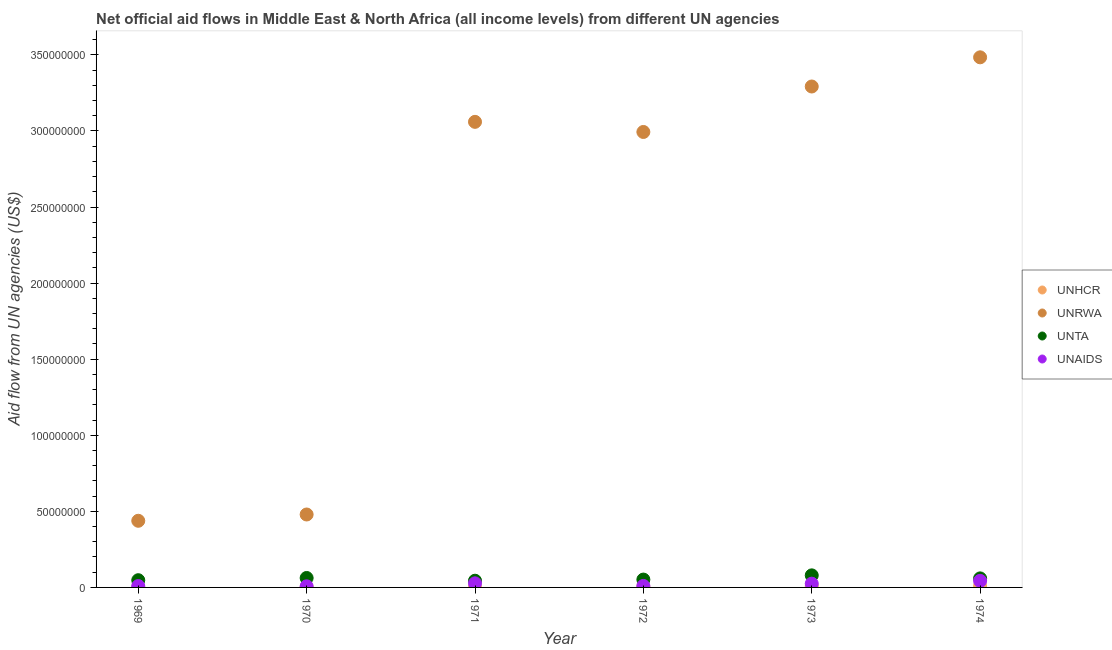How many different coloured dotlines are there?
Make the answer very short. 4. What is the amount of aid given by unrwa in 1972?
Give a very brief answer. 2.99e+08. Across all years, what is the maximum amount of aid given by unta?
Keep it short and to the point. 7.93e+06. Across all years, what is the minimum amount of aid given by unaids?
Give a very brief answer. 7.40e+05. In which year was the amount of aid given by unrwa maximum?
Your answer should be compact. 1974. In which year was the amount of aid given by unta minimum?
Offer a terse response. 1971. What is the total amount of aid given by unaids in the graph?
Your response must be concise. 1.21e+07. What is the difference between the amount of aid given by unta in 1974 and the amount of aid given by unaids in 1970?
Offer a very short reply. 5.20e+06. What is the average amount of aid given by unaids per year?
Your answer should be very brief. 2.02e+06. In the year 1973, what is the difference between the amount of aid given by unta and amount of aid given by unaids?
Give a very brief answer. 5.46e+06. In how many years, is the amount of aid given by unaids greater than 120000000 US$?
Provide a short and direct response. 0. What is the ratio of the amount of aid given by unaids in 1970 to that in 1974?
Your answer should be compact. 0.17. What is the difference between the highest and the second highest amount of aid given by unaids?
Offer a terse response. 1.64e+06. What is the difference between the highest and the lowest amount of aid given by unaids?
Your answer should be compact. 3.58e+06. Does the amount of aid given by unta monotonically increase over the years?
Offer a very short reply. No. Is the amount of aid given by unhcr strictly greater than the amount of aid given by unaids over the years?
Your answer should be very brief. No. Is the amount of aid given by unrwa strictly less than the amount of aid given by unta over the years?
Keep it short and to the point. No. How many dotlines are there?
Give a very brief answer. 4. Does the graph contain grids?
Make the answer very short. No. Where does the legend appear in the graph?
Make the answer very short. Center right. How are the legend labels stacked?
Offer a very short reply. Vertical. What is the title of the graph?
Ensure brevity in your answer.  Net official aid flows in Middle East & North Africa (all income levels) from different UN agencies. Does "First 20% of population" appear as one of the legend labels in the graph?
Your answer should be compact. No. What is the label or title of the Y-axis?
Provide a succinct answer. Aid flow from UN agencies (US$). What is the Aid flow from UN agencies (US$) in UNHCR in 1969?
Keep it short and to the point. 1.40e+05. What is the Aid flow from UN agencies (US$) of UNRWA in 1969?
Your answer should be very brief. 4.38e+07. What is the Aid flow from UN agencies (US$) of UNTA in 1969?
Provide a succinct answer. 4.75e+06. What is the Aid flow from UN agencies (US$) in UNAIDS in 1969?
Provide a succinct answer. 9.10e+05. What is the Aid flow from UN agencies (US$) in UNHCR in 1970?
Offer a very short reply. 1.70e+05. What is the Aid flow from UN agencies (US$) in UNRWA in 1970?
Offer a very short reply. 4.79e+07. What is the Aid flow from UN agencies (US$) in UNTA in 1970?
Offer a very short reply. 6.21e+06. What is the Aid flow from UN agencies (US$) of UNAIDS in 1970?
Your response must be concise. 7.40e+05. What is the Aid flow from UN agencies (US$) of UNHCR in 1971?
Give a very brief answer. 1.40e+05. What is the Aid flow from UN agencies (US$) of UNRWA in 1971?
Ensure brevity in your answer.  3.06e+08. What is the Aid flow from UN agencies (US$) of UNTA in 1971?
Your answer should be very brief. 4.41e+06. What is the Aid flow from UN agencies (US$) in UNAIDS in 1971?
Ensure brevity in your answer.  2.68e+06. What is the Aid flow from UN agencies (US$) in UNRWA in 1972?
Ensure brevity in your answer.  2.99e+08. What is the Aid flow from UN agencies (US$) in UNTA in 1972?
Provide a succinct answer. 5.16e+06. What is the Aid flow from UN agencies (US$) in UNAIDS in 1972?
Give a very brief answer. 9.80e+05. What is the Aid flow from UN agencies (US$) of UNHCR in 1973?
Your response must be concise. 8.80e+05. What is the Aid flow from UN agencies (US$) of UNRWA in 1973?
Ensure brevity in your answer.  3.29e+08. What is the Aid flow from UN agencies (US$) in UNTA in 1973?
Give a very brief answer. 7.93e+06. What is the Aid flow from UN agencies (US$) in UNAIDS in 1973?
Provide a short and direct response. 2.47e+06. What is the Aid flow from UN agencies (US$) of UNHCR in 1974?
Ensure brevity in your answer.  9.70e+05. What is the Aid flow from UN agencies (US$) of UNRWA in 1974?
Keep it short and to the point. 3.48e+08. What is the Aid flow from UN agencies (US$) of UNTA in 1974?
Give a very brief answer. 5.94e+06. What is the Aid flow from UN agencies (US$) in UNAIDS in 1974?
Keep it short and to the point. 4.32e+06. Across all years, what is the maximum Aid flow from UN agencies (US$) of UNHCR?
Give a very brief answer. 9.70e+05. Across all years, what is the maximum Aid flow from UN agencies (US$) in UNRWA?
Ensure brevity in your answer.  3.48e+08. Across all years, what is the maximum Aid flow from UN agencies (US$) of UNTA?
Provide a succinct answer. 7.93e+06. Across all years, what is the maximum Aid flow from UN agencies (US$) in UNAIDS?
Your answer should be compact. 4.32e+06. Across all years, what is the minimum Aid flow from UN agencies (US$) of UNHCR?
Your answer should be compact. 1.40e+05. Across all years, what is the minimum Aid flow from UN agencies (US$) in UNRWA?
Offer a very short reply. 4.38e+07. Across all years, what is the minimum Aid flow from UN agencies (US$) in UNTA?
Provide a succinct answer. 4.41e+06. Across all years, what is the minimum Aid flow from UN agencies (US$) in UNAIDS?
Keep it short and to the point. 7.40e+05. What is the total Aid flow from UN agencies (US$) in UNHCR in the graph?
Ensure brevity in your answer.  2.76e+06. What is the total Aid flow from UN agencies (US$) of UNRWA in the graph?
Provide a succinct answer. 1.37e+09. What is the total Aid flow from UN agencies (US$) in UNTA in the graph?
Make the answer very short. 3.44e+07. What is the total Aid flow from UN agencies (US$) of UNAIDS in the graph?
Provide a short and direct response. 1.21e+07. What is the difference between the Aid flow from UN agencies (US$) in UNRWA in 1969 and that in 1970?
Offer a terse response. -4.13e+06. What is the difference between the Aid flow from UN agencies (US$) of UNTA in 1969 and that in 1970?
Your answer should be compact. -1.46e+06. What is the difference between the Aid flow from UN agencies (US$) of UNAIDS in 1969 and that in 1970?
Make the answer very short. 1.70e+05. What is the difference between the Aid flow from UN agencies (US$) in UNRWA in 1969 and that in 1971?
Provide a succinct answer. -2.62e+08. What is the difference between the Aid flow from UN agencies (US$) of UNAIDS in 1969 and that in 1971?
Your answer should be compact. -1.77e+06. What is the difference between the Aid flow from UN agencies (US$) in UNHCR in 1969 and that in 1972?
Provide a short and direct response. -3.20e+05. What is the difference between the Aid flow from UN agencies (US$) of UNRWA in 1969 and that in 1972?
Ensure brevity in your answer.  -2.56e+08. What is the difference between the Aid flow from UN agencies (US$) in UNTA in 1969 and that in 1972?
Keep it short and to the point. -4.10e+05. What is the difference between the Aid flow from UN agencies (US$) in UNAIDS in 1969 and that in 1972?
Provide a succinct answer. -7.00e+04. What is the difference between the Aid flow from UN agencies (US$) of UNHCR in 1969 and that in 1973?
Offer a terse response. -7.40e+05. What is the difference between the Aid flow from UN agencies (US$) in UNRWA in 1969 and that in 1973?
Your answer should be very brief. -2.85e+08. What is the difference between the Aid flow from UN agencies (US$) in UNTA in 1969 and that in 1973?
Give a very brief answer. -3.18e+06. What is the difference between the Aid flow from UN agencies (US$) of UNAIDS in 1969 and that in 1973?
Keep it short and to the point. -1.56e+06. What is the difference between the Aid flow from UN agencies (US$) of UNHCR in 1969 and that in 1974?
Make the answer very short. -8.30e+05. What is the difference between the Aid flow from UN agencies (US$) of UNRWA in 1969 and that in 1974?
Your answer should be compact. -3.05e+08. What is the difference between the Aid flow from UN agencies (US$) of UNTA in 1969 and that in 1974?
Keep it short and to the point. -1.19e+06. What is the difference between the Aid flow from UN agencies (US$) of UNAIDS in 1969 and that in 1974?
Make the answer very short. -3.41e+06. What is the difference between the Aid flow from UN agencies (US$) of UNRWA in 1970 and that in 1971?
Ensure brevity in your answer.  -2.58e+08. What is the difference between the Aid flow from UN agencies (US$) of UNTA in 1970 and that in 1971?
Make the answer very short. 1.80e+06. What is the difference between the Aid flow from UN agencies (US$) of UNAIDS in 1970 and that in 1971?
Give a very brief answer. -1.94e+06. What is the difference between the Aid flow from UN agencies (US$) in UNRWA in 1970 and that in 1972?
Offer a terse response. -2.51e+08. What is the difference between the Aid flow from UN agencies (US$) in UNTA in 1970 and that in 1972?
Keep it short and to the point. 1.05e+06. What is the difference between the Aid flow from UN agencies (US$) of UNAIDS in 1970 and that in 1972?
Your answer should be very brief. -2.40e+05. What is the difference between the Aid flow from UN agencies (US$) of UNHCR in 1970 and that in 1973?
Keep it short and to the point. -7.10e+05. What is the difference between the Aid flow from UN agencies (US$) of UNRWA in 1970 and that in 1973?
Ensure brevity in your answer.  -2.81e+08. What is the difference between the Aid flow from UN agencies (US$) in UNTA in 1970 and that in 1973?
Your answer should be very brief. -1.72e+06. What is the difference between the Aid flow from UN agencies (US$) of UNAIDS in 1970 and that in 1973?
Your answer should be compact. -1.73e+06. What is the difference between the Aid flow from UN agencies (US$) in UNHCR in 1970 and that in 1974?
Make the answer very short. -8.00e+05. What is the difference between the Aid flow from UN agencies (US$) in UNRWA in 1970 and that in 1974?
Give a very brief answer. -3.00e+08. What is the difference between the Aid flow from UN agencies (US$) of UNTA in 1970 and that in 1974?
Offer a terse response. 2.70e+05. What is the difference between the Aid flow from UN agencies (US$) of UNAIDS in 1970 and that in 1974?
Offer a terse response. -3.58e+06. What is the difference between the Aid flow from UN agencies (US$) of UNHCR in 1971 and that in 1972?
Your response must be concise. -3.20e+05. What is the difference between the Aid flow from UN agencies (US$) in UNRWA in 1971 and that in 1972?
Provide a short and direct response. 6.65e+06. What is the difference between the Aid flow from UN agencies (US$) of UNTA in 1971 and that in 1972?
Offer a very short reply. -7.50e+05. What is the difference between the Aid flow from UN agencies (US$) of UNAIDS in 1971 and that in 1972?
Your answer should be very brief. 1.70e+06. What is the difference between the Aid flow from UN agencies (US$) in UNHCR in 1971 and that in 1973?
Give a very brief answer. -7.40e+05. What is the difference between the Aid flow from UN agencies (US$) in UNRWA in 1971 and that in 1973?
Give a very brief answer. -2.32e+07. What is the difference between the Aid flow from UN agencies (US$) of UNTA in 1971 and that in 1973?
Give a very brief answer. -3.52e+06. What is the difference between the Aid flow from UN agencies (US$) of UNHCR in 1971 and that in 1974?
Your answer should be very brief. -8.30e+05. What is the difference between the Aid flow from UN agencies (US$) of UNRWA in 1971 and that in 1974?
Your answer should be very brief. -4.24e+07. What is the difference between the Aid flow from UN agencies (US$) of UNTA in 1971 and that in 1974?
Offer a terse response. -1.53e+06. What is the difference between the Aid flow from UN agencies (US$) of UNAIDS in 1971 and that in 1974?
Ensure brevity in your answer.  -1.64e+06. What is the difference between the Aid flow from UN agencies (US$) of UNHCR in 1972 and that in 1973?
Your answer should be compact. -4.20e+05. What is the difference between the Aid flow from UN agencies (US$) of UNRWA in 1972 and that in 1973?
Ensure brevity in your answer.  -2.99e+07. What is the difference between the Aid flow from UN agencies (US$) of UNTA in 1972 and that in 1973?
Provide a succinct answer. -2.77e+06. What is the difference between the Aid flow from UN agencies (US$) of UNAIDS in 1972 and that in 1973?
Your response must be concise. -1.49e+06. What is the difference between the Aid flow from UN agencies (US$) in UNHCR in 1972 and that in 1974?
Your response must be concise. -5.10e+05. What is the difference between the Aid flow from UN agencies (US$) in UNRWA in 1972 and that in 1974?
Offer a terse response. -4.91e+07. What is the difference between the Aid flow from UN agencies (US$) in UNTA in 1972 and that in 1974?
Your answer should be very brief. -7.80e+05. What is the difference between the Aid flow from UN agencies (US$) of UNAIDS in 1972 and that in 1974?
Offer a very short reply. -3.34e+06. What is the difference between the Aid flow from UN agencies (US$) of UNRWA in 1973 and that in 1974?
Your answer should be very brief. -1.92e+07. What is the difference between the Aid flow from UN agencies (US$) of UNTA in 1973 and that in 1974?
Give a very brief answer. 1.99e+06. What is the difference between the Aid flow from UN agencies (US$) in UNAIDS in 1973 and that in 1974?
Offer a terse response. -1.85e+06. What is the difference between the Aid flow from UN agencies (US$) in UNHCR in 1969 and the Aid flow from UN agencies (US$) in UNRWA in 1970?
Your answer should be very brief. -4.78e+07. What is the difference between the Aid flow from UN agencies (US$) in UNHCR in 1969 and the Aid flow from UN agencies (US$) in UNTA in 1970?
Provide a short and direct response. -6.07e+06. What is the difference between the Aid flow from UN agencies (US$) in UNHCR in 1969 and the Aid flow from UN agencies (US$) in UNAIDS in 1970?
Provide a succinct answer. -6.00e+05. What is the difference between the Aid flow from UN agencies (US$) of UNRWA in 1969 and the Aid flow from UN agencies (US$) of UNTA in 1970?
Your answer should be very brief. 3.76e+07. What is the difference between the Aid flow from UN agencies (US$) in UNRWA in 1969 and the Aid flow from UN agencies (US$) in UNAIDS in 1970?
Ensure brevity in your answer.  4.31e+07. What is the difference between the Aid flow from UN agencies (US$) of UNTA in 1969 and the Aid flow from UN agencies (US$) of UNAIDS in 1970?
Provide a short and direct response. 4.01e+06. What is the difference between the Aid flow from UN agencies (US$) in UNHCR in 1969 and the Aid flow from UN agencies (US$) in UNRWA in 1971?
Your response must be concise. -3.06e+08. What is the difference between the Aid flow from UN agencies (US$) of UNHCR in 1969 and the Aid flow from UN agencies (US$) of UNTA in 1971?
Provide a succinct answer. -4.27e+06. What is the difference between the Aid flow from UN agencies (US$) in UNHCR in 1969 and the Aid flow from UN agencies (US$) in UNAIDS in 1971?
Your answer should be very brief. -2.54e+06. What is the difference between the Aid flow from UN agencies (US$) in UNRWA in 1969 and the Aid flow from UN agencies (US$) in UNTA in 1971?
Offer a terse response. 3.94e+07. What is the difference between the Aid flow from UN agencies (US$) in UNRWA in 1969 and the Aid flow from UN agencies (US$) in UNAIDS in 1971?
Provide a succinct answer. 4.11e+07. What is the difference between the Aid flow from UN agencies (US$) of UNTA in 1969 and the Aid flow from UN agencies (US$) of UNAIDS in 1971?
Your answer should be very brief. 2.07e+06. What is the difference between the Aid flow from UN agencies (US$) in UNHCR in 1969 and the Aid flow from UN agencies (US$) in UNRWA in 1972?
Offer a terse response. -2.99e+08. What is the difference between the Aid flow from UN agencies (US$) of UNHCR in 1969 and the Aid flow from UN agencies (US$) of UNTA in 1972?
Provide a short and direct response. -5.02e+06. What is the difference between the Aid flow from UN agencies (US$) in UNHCR in 1969 and the Aid flow from UN agencies (US$) in UNAIDS in 1972?
Your answer should be very brief. -8.40e+05. What is the difference between the Aid flow from UN agencies (US$) in UNRWA in 1969 and the Aid flow from UN agencies (US$) in UNTA in 1972?
Keep it short and to the point. 3.86e+07. What is the difference between the Aid flow from UN agencies (US$) in UNRWA in 1969 and the Aid flow from UN agencies (US$) in UNAIDS in 1972?
Make the answer very short. 4.28e+07. What is the difference between the Aid flow from UN agencies (US$) in UNTA in 1969 and the Aid flow from UN agencies (US$) in UNAIDS in 1972?
Keep it short and to the point. 3.77e+06. What is the difference between the Aid flow from UN agencies (US$) in UNHCR in 1969 and the Aid flow from UN agencies (US$) in UNRWA in 1973?
Give a very brief answer. -3.29e+08. What is the difference between the Aid flow from UN agencies (US$) of UNHCR in 1969 and the Aid flow from UN agencies (US$) of UNTA in 1973?
Give a very brief answer. -7.79e+06. What is the difference between the Aid flow from UN agencies (US$) in UNHCR in 1969 and the Aid flow from UN agencies (US$) in UNAIDS in 1973?
Keep it short and to the point. -2.33e+06. What is the difference between the Aid flow from UN agencies (US$) of UNRWA in 1969 and the Aid flow from UN agencies (US$) of UNTA in 1973?
Ensure brevity in your answer.  3.59e+07. What is the difference between the Aid flow from UN agencies (US$) of UNRWA in 1969 and the Aid flow from UN agencies (US$) of UNAIDS in 1973?
Provide a succinct answer. 4.13e+07. What is the difference between the Aid flow from UN agencies (US$) of UNTA in 1969 and the Aid flow from UN agencies (US$) of UNAIDS in 1973?
Ensure brevity in your answer.  2.28e+06. What is the difference between the Aid flow from UN agencies (US$) of UNHCR in 1969 and the Aid flow from UN agencies (US$) of UNRWA in 1974?
Your response must be concise. -3.48e+08. What is the difference between the Aid flow from UN agencies (US$) in UNHCR in 1969 and the Aid flow from UN agencies (US$) in UNTA in 1974?
Your answer should be very brief. -5.80e+06. What is the difference between the Aid flow from UN agencies (US$) of UNHCR in 1969 and the Aid flow from UN agencies (US$) of UNAIDS in 1974?
Offer a very short reply. -4.18e+06. What is the difference between the Aid flow from UN agencies (US$) in UNRWA in 1969 and the Aid flow from UN agencies (US$) in UNTA in 1974?
Give a very brief answer. 3.79e+07. What is the difference between the Aid flow from UN agencies (US$) of UNRWA in 1969 and the Aid flow from UN agencies (US$) of UNAIDS in 1974?
Offer a terse response. 3.95e+07. What is the difference between the Aid flow from UN agencies (US$) in UNHCR in 1970 and the Aid flow from UN agencies (US$) in UNRWA in 1971?
Your answer should be compact. -3.06e+08. What is the difference between the Aid flow from UN agencies (US$) of UNHCR in 1970 and the Aid flow from UN agencies (US$) of UNTA in 1971?
Provide a succinct answer. -4.24e+06. What is the difference between the Aid flow from UN agencies (US$) in UNHCR in 1970 and the Aid flow from UN agencies (US$) in UNAIDS in 1971?
Provide a succinct answer. -2.51e+06. What is the difference between the Aid flow from UN agencies (US$) of UNRWA in 1970 and the Aid flow from UN agencies (US$) of UNTA in 1971?
Offer a terse response. 4.35e+07. What is the difference between the Aid flow from UN agencies (US$) of UNRWA in 1970 and the Aid flow from UN agencies (US$) of UNAIDS in 1971?
Make the answer very short. 4.52e+07. What is the difference between the Aid flow from UN agencies (US$) of UNTA in 1970 and the Aid flow from UN agencies (US$) of UNAIDS in 1971?
Make the answer very short. 3.53e+06. What is the difference between the Aid flow from UN agencies (US$) of UNHCR in 1970 and the Aid flow from UN agencies (US$) of UNRWA in 1972?
Provide a succinct answer. -2.99e+08. What is the difference between the Aid flow from UN agencies (US$) of UNHCR in 1970 and the Aid flow from UN agencies (US$) of UNTA in 1972?
Your answer should be very brief. -4.99e+06. What is the difference between the Aid flow from UN agencies (US$) of UNHCR in 1970 and the Aid flow from UN agencies (US$) of UNAIDS in 1972?
Offer a very short reply. -8.10e+05. What is the difference between the Aid flow from UN agencies (US$) in UNRWA in 1970 and the Aid flow from UN agencies (US$) in UNTA in 1972?
Your answer should be very brief. 4.28e+07. What is the difference between the Aid flow from UN agencies (US$) in UNRWA in 1970 and the Aid flow from UN agencies (US$) in UNAIDS in 1972?
Give a very brief answer. 4.70e+07. What is the difference between the Aid flow from UN agencies (US$) in UNTA in 1970 and the Aid flow from UN agencies (US$) in UNAIDS in 1972?
Keep it short and to the point. 5.23e+06. What is the difference between the Aid flow from UN agencies (US$) in UNHCR in 1970 and the Aid flow from UN agencies (US$) in UNRWA in 1973?
Ensure brevity in your answer.  -3.29e+08. What is the difference between the Aid flow from UN agencies (US$) of UNHCR in 1970 and the Aid flow from UN agencies (US$) of UNTA in 1973?
Your answer should be very brief. -7.76e+06. What is the difference between the Aid flow from UN agencies (US$) of UNHCR in 1970 and the Aid flow from UN agencies (US$) of UNAIDS in 1973?
Your answer should be very brief. -2.30e+06. What is the difference between the Aid flow from UN agencies (US$) in UNRWA in 1970 and the Aid flow from UN agencies (US$) in UNTA in 1973?
Your answer should be compact. 4.00e+07. What is the difference between the Aid flow from UN agencies (US$) in UNRWA in 1970 and the Aid flow from UN agencies (US$) in UNAIDS in 1973?
Your answer should be compact. 4.55e+07. What is the difference between the Aid flow from UN agencies (US$) in UNTA in 1970 and the Aid flow from UN agencies (US$) in UNAIDS in 1973?
Make the answer very short. 3.74e+06. What is the difference between the Aid flow from UN agencies (US$) of UNHCR in 1970 and the Aid flow from UN agencies (US$) of UNRWA in 1974?
Keep it short and to the point. -3.48e+08. What is the difference between the Aid flow from UN agencies (US$) of UNHCR in 1970 and the Aid flow from UN agencies (US$) of UNTA in 1974?
Provide a short and direct response. -5.77e+06. What is the difference between the Aid flow from UN agencies (US$) of UNHCR in 1970 and the Aid flow from UN agencies (US$) of UNAIDS in 1974?
Your answer should be compact. -4.15e+06. What is the difference between the Aid flow from UN agencies (US$) in UNRWA in 1970 and the Aid flow from UN agencies (US$) in UNTA in 1974?
Provide a succinct answer. 4.20e+07. What is the difference between the Aid flow from UN agencies (US$) in UNRWA in 1970 and the Aid flow from UN agencies (US$) in UNAIDS in 1974?
Offer a very short reply. 4.36e+07. What is the difference between the Aid flow from UN agencies (US$) of UNTA in 1970 and the Aid flow from UN agencies (US$) of UNAIDS in 1974?
Offer a very short reply. 1.89e+06. What is the difference between the Aid flow from UN agencies (US$) of UNHCR in 1971 and the Aid flow from UN agencies (US$) of UNRWA in 1972?
Keep it short and to the point. -2.99e+08. What is the difference between the Aid flow from UN agencies (US$) in UNHCR in 1971 and the Aid flow from UN agencies (US$) in UNTA in 1972?
Your answer should be very brief. -5.02e+06. What is the difference between the Aid flow from UN agencies (US$) of UNHCR in 1971 and the Aid flow from UN agencies (US$) of UNAIDS in 1972?
Make the answer very short. -8.40e+05. What is the difference between the Aid flow from UN agencies (US$) in UNRWA in 1971 and the Aid flow from UN agencies (US$) in UNTA in 1972?
Your answer should be compact. 3.01e+08. What is the difference between the Aid flow from UN agencies (US$) in UNRWA in 1971 and the Aid flow from UN agencies (US$) in UNAIDS in 1972?
Keep it short and to the point. 3.05e+08. What is the difference between the Aid flow from UN agencies (US$) of UNTA in 1971 and the Aid flow from UN agencies (US$) of UNAIDS in 1972?
Offer a terse response. 3.43e+06. What is the difference between the Aid flow from UN agencies (US$) in UNHCR in 1971 and the Aid flow from UN agencies (US$) in UNRWA in 1973?
Your response must be concise. -3.29e+08. What is the difference between the Aid flow from UN agencies (US$) in UNHCR in 1971 and the Aid flow from UN agencies (US$) in UNTA in 1973?
Your answer should be very brief. -7.79e+06. What is the difference between the Aid flow from UN agencies (US$) in UNHCR in 1971 and the Aid flow from UN agencies (US$) in UNAIDS in 1973?
Your answer should be compact. -2.33e+06. What is the difference between the Aid flow from UN agencies (US$) in UNRWA in 1971 and the Aid flow from UN agencies (US$) in UNTA in 1973?
Your answer should be very brief. 2.98e+08. What is the difference between the Aid flow from UN agencies (US$) in UNRWA in 1971 and the Aid flow from UN agencies (US$) in UNAIDS in 1973?
Your response must be concise. 3.04e+08. What is the difference between the Aid flow from UN agencies (US$) in UNTA in 1971 and the Aid flow from UN agencies (US$) in UNAIDS in 1973?
Your answer should be very brief. 1.94e+06. What is the difference between the Aid flow from UN agencies (US$) in UNHCR in 1971 and the Aid flow from UN agencies (US$) in UNRWA in 1974?
Your answer should be very brief. -3.48e+08. What is the difference between the Aid flow from UN agencies (US$) in UNHCR in 1971 and the Aid flow from UN agencies (US$) in UNTA in 1974?
Provide a succinct answer. -5.80e+06. What is the difference between the Aid flow from UN agencies (US$) of UNHCR in 1971 and the Aid flow from UN agencies (US$) of UNAIDS in 1974?
Offer a terse response. -4.18e+06. What is the difference between the Aid flow from UN agencies (US$) of UNRWA in 1971 and the Aid flow from UN agencies (US$) of UNTA in 1974?
Offer a terse response. 3.00e+08. What is the difference between the Aid flow from UN agencies (US$) in UNRWA in 1971 and the Aid flow from UN agencies (US$) in UNAIDS in 1974?
Offer a very short reply. 3.02e+08. What is the difference between the Aid flow from UN agencies (US$) of UNTA in 1971 and the Aid flow from UN agencies (US$) of UNAIDS in 1974?
Provide a succinct answer. 9.00e+04. What is the difference between the Aid flow from UN agencies (US$) of UNHCR in 1972 and the Aid flow from UN agencies (US$) of UNRWA in 1973?
Ensure brevity in your answer.  -3.29e+08. What is the difference between the Aid flow from UN agencies (US$) in UNHCR in 1972 and the Aid flow from UN agencies (US$) in UNTA in 1973?
Provide a short and direct response. -7.47e+06. What is the difference between the Aid flow from UN agencies (US$) of UNHCR in 1972 and the Aid flow from UN agencies (US$) of UNAIDS in 1973?
Make the answer very short. -2.01e+06. What is the difference between the Aid flow from UN agencies (US$) in UNRWA in 1972 and the Aid flow from UN agencies (US$) in UNTA in 1973?
Offer a terse response. 2.91e+08. What is the difference between the Aid flow from UN agencies (US$) in UNRWA in 1972 and the Aid flow from UN agencies (US$) in UNAIDS in 1973?
Provide a succinct answer. 2.97e+08. What is the difference between the Aid flow from UN agencies (US$) of UNTA in 1972 and the Aid flow from UN agencies (US$) of UNAIDS in 1973?
Keep it short and to the point. 2.69e+06. What is the difference between the Aid flow from UN agencies (US$) of UNHCR in 1972 and the Aid flow from UN agencies (US$) of UNRWA in 1974?
Your answer should be compact. -3.48e+08. What is the difference between the Aid flow from UN agencies (US$) in UNHCR in 1972 and the Aid flow from UN agencies (US$) in UNTA in 1974?
Provide a short and direct response. -5.48e+06. What is the difference between the Aid flow from UN agencies (US$) of UNHCR in 1972 and the Aid flow from UN agencies (US$) of UNAIDS in 1974?
Your answer should be compact. -3.86e+06. What is the difference between the Aid flow from UN agencies (US$) in UNRWA in 1972 and the Aid flow from UN agencies (US$) in UNTA in 1974?
Make the answer very short. 2.93e+08. What is the difference between the Aid flow from UN agencies (US$) in UNRWA in 1972 and the Aid flow from UN agencies (US$) in UNAIDS in 1974?
Keep it short and to the point. 2.95e+08. What is the difference between the Aid flow from UN agencies (US$) of UNTA in 1972 and the Aid flow from UN agencies (US$) of UNAIDS in 1974?
Give a very brief answer. 8.40e+05. What is the difference between the Aid flow from UN agencies (US$) in UNHCR in 1973 and the Aid flow from UN agencies (US$) in UNRWA in 1974?
Your answer should be very brief. -3.48e+08. What is the difference between the Aid flow from UN agencies (US$) in UNHCR in 1973 and the Aid flow from UN agencies (US$) in UNTA in 1974?
Provide a short and direct response. -5.06e+06. What is the difference between the Aid flow from UN agencies (US$) of UNHCR in 1973 and the Aid flow from UN agencies (US$) of UNAIDS in 1974?
Your response must be concise. -3.44e+06. What is the difference between the Aid flow from UN agencies (US$) in UNRWA in 1973 and the Aid flow from UN agencies (US$) in UNTA in 1974?
Your answer should be compact. 3.23e+08. What is the difference between the Aid flow from UN agencies (US$) of UNRWA in 1973 and the Aid flow from UN agencies (US$) of UNAIDS in 1974?
Offer a very short reply. 3.25e+08. What is the difference between the Aid flow from UN agencies (US$) of UNTA in 1973 and the Aid flow from UN agencies (US$) of UNAIDS in 1974?
Offer a terse response. 3.61e+06. What is the average Aid flow from UN agencies (US$) of UNHCR per year?
Ensure brevity in your answer.  4.60e+05. What is the average Aid flow from UN agencies (US$) of UNRWA per year?
Ensure brevity in your answer.  2.29e+08. What is the average Aid flow from UN agencies (US$) in UNTA per year?
Make the answer very short. 5.73e+06. What is the average Aid flow from UN agencies (US$) of UNAIDS per year?
Ensure brevity in your answer.  2.02e+06. In the year 1969, what is the difference between the Aid flow from UN agencies (US$) of UNHCR and Aid flow from UN agencies (US$) of UNRWA?
Offer a very short reply. -4.37e+07. In the year 1969, what is the difference between the Aid flow from UN agencies (US$) of UNHCR and Aid flow from UN agencies (US$) of UNTA?
Offer a very short reply. -4.61e+06. In the year 1969, what is the difference between the Aid flow from UN agencies (US$) in UNHCR and Aid flow from UN agencies (US$) in UNAIDS?
Your response must be concise. -7.70e+05. In the year 1969, what is the difference between the Aid flow from UN agencies (US$) of UNRWA and Aid flow from UN agencies (US$) of UNTA?
Ensure brevity in your answer.  3.90e+07. In the year 1969, what is the difference between the Aid flow from UN agencies (US$) in UNRWA and Aid flow from UN agencies (US$) in UNAIDS?
Your answer should be very brief. 4.29e+07. In the year 1969, what is the difference between the Aid flow from UN agencies (US$) of UNTA and Aid flow from UN agencies (US$) of UNAIDS?
Provide a short and direct response. 3.84e+06. In the year 1970, what is the difference between the Aid flow from UN agencies (US$) of UNHCR and Aid flow from UN agencies (US$) of UNRWA?
Offer a very short reply. -4.78e+07. In the year 1970, what is the difference between the Aid flow from UN agencies (US$) in UNHCR and Aid flow from UN agencies (US$) in UNTA?
Provide a short and direct response. -6.04e+06. In the year 1970, what is the difference between the Aid flow from UN agencies (US$) in UNHCR and Aid flow from UN agencies (US$) in UNAIDS?
Make the answer very short. -5.70e+05. In the year 1970, what is the difference between the Aid flow from UN agencies (US$) of UNRWA and Aid flow from UN agencies (US$) of UNTA?
Provide a succinct answer. 4.17e+07. In the year 1970, what is the difference between the Aid flow from UN agencies (US$) of UNRWA and Aid flow from UN agencies (US$) of UNAIDS?
Keep it short and to the point. 4.72e+07. In the year 1970, what is the difference between the Aid flow from UN agencies (US$) of UNTA and Aid flow from UN agencies (US$) of UNAIDS?
Your answer should be very brief. 5.47e+06. In the year 1971, what is the difference between the Aid flow from UN agencies (US$) in UNHCR and Aid flow from UN agencies (US$) in UNRWA?
Provide a succinct answer. -3.06e+08. In the year 1971, what is the difference between the Aid flow from UN agencies (US$) in UNHCR and Aid flow from UN agencies (US$) in UNTA?
Your answer should be compact. -4.27e+06. In the year 1971, what is the difference between the Aid flow from UN agencies (US$) of UNHCR and Aid flow from UN agencies (US$) of UNAIDS?
Provide a succinct answer. -2.54e+06. In the year 1971, what is the difference between the Aid flow from UN agencies (US$) of UNRWA and Aid flow from UN agencies (US$) of UNTA?
Make the answer very short. 3.02e+08. In the year 1971, what is the difference between the Aid flow from UN agencies (US$) of UNRWA and Aid flow from UN agencies (US$) of UNAIDS?
Provide a succinct answer. 3.03e+08. In the year 1971, what is the difference between the Aid flow from UN agencies (US$) of UNTA and Aid flow from UN agencies (US$) of UNAIDS?
Your response must be concise. 1.73e+06. In the year 1972, what is the difference between the Aid flow from UN agencies (US$) of UNHCR and Aid flow from UN agencies (US$) of UNRWA?
Your answer should be compact. -2.99e+08. In the year 1972, what is the difference between the Aid flow from UN agencies (US$) in UNHCR and Aid flow from UN agencies (US$) in UNTA?
Your response must be concise. -4.70e+06. In the year 1972, what is the difference between the Aid flow from UN agencies (US$) of UNHCR and Aid flow from UN agencies (US$) of UNAIDS?
Ensure brevity in your answer.  -5.20e+05. In the year 1972, what is the difference between the Aid flow from UN agencies (US$) of UNRWA and Aid flow from UN agencies (US$) of UNTA?
Your answer should be very brief. 2.94e+08. In the year 1972, what is the difference between the Aid flow from UN agencies (US$) of UNRWA and Aid flow from UN agencies (US$) of UNAIDS?
Your answer should be compact. 2.98e+08. In the year 1972, what is the difference between the Aid flow from UN agencies (US$) in UNTA and Aid flow from UN agencies (US$) in UNAIDS?
Provide a short and direct response. 4.18e+06. In the year 1973, what is the difference between the Aid flow from UN agencies (US$) in UNHCR and Aid flow from UN agencies (US$) in UNRWA?
Make the answer very short. -3.28e+08. In the year 1973, what is the difference between the Aid flow from UN agencies (US$) in UNHCR and Aid flow from UN agencies (US$) in UNTA?
Offer a terse response. -7.05e+06. In the year 1973, what is the difference between the Aid flow from UN agencies (US$) of UNHCR and Aid flow from UN agencies (US$) of UNAIDS?
Keep it short and to the point. -1.59e+06. In the year 1973, what is the difference between the Aid flow from UN agencies (US$) of UNRWA and Aid flow from UN agencies (US$) of UNTA?
Offer a very short reply. 3.21e+08. In the year 1973, what is the difference between the Aid flow from UN agencies (US$) of UNRWA and Aid flow from UN agencies (US$) of UNAIDS?
Provide a short and direct response. 3.27e+08. In the year 1973, what is the difference between the Aid flow from UN agencies (US$) of UNTA and Aid flow from UN agencies (US$) of UNAIDS?
Offer a terse response. 5.46e+06. In the year 1974, what is the difference between the Aid flow from UN agencies (US$) in UNHCR and Aid flow from UN agencies (US$) in UNRWA?
Offer a very short reply. -3.47e+08. In the year 1974, what is the difference between the Aid flow from UN agencies (US$) in UNHCR and Aid flow from UN agencies (US$) in UNTA?
Ensure brevity in your answer.  -4.97e+06. In the year 1974, what is the difference between the Aid flow from UN agencies (US$) in UNHCR and Aid flow from UN agencies (US$) in UNAIDS?
Keep it short and to the point. -3.35e+06. In the year 1974, what is the difference between the Aid flow from UN agencies (US$) of UNRWA and Aid flow from UN agencies (US$) of UNTA?
Offer a very short reply. 3.42e+08. In the year 1974, what is the difference between the Aid flow from UN agencies (US$) of UNRWA and Aid flow from UN agencies (US$) of UNAIDS?
Your answer should be very brief. 3.44e+08. In the year 1974, what is the difference between the Aid flow from UN agencies (US$) of UNTA and Aid flow from UN agencies (US$) of UNAIDS?
Make the answer very short. 1.62e+06. What is the ratio of the Aid flow from UN agencies (US$) of UNHCR in 1969 to that in 1970?
Provide a short and direct response. 0.82. What is the ratio of the Aid flow from UN agencies (US$) of UNRWA in 1969 to that in 1970?
Your answer should be compact. 0.91. What is the ratio of the Aid flow from UN agencies (US$) in UNTA in 1969 to that in 1970?
Offer a terse response. 0.76. What is the ratio of the Aid flow from UN agencies (US$) in UNAIDS in 1969 to that in 1970?
Ensure brevity in your answer.  1.23. What is the ratio of the Aid flow from UN agencies (US$) of UNRWA in 1969 to that in 1971?
Offer a terse response. 0.14. What is the ratio of the Aid flow from UN agencies (US$) of UNTA in 1969 to that in 1971?
Offer a very short reply. 1.08. What is the ratio of the Aid flow from UN agencies (US$) of UNAIDS in 1969 to that in 1971?
Your answer should be compact. 0.34. What is the ratio of the Aid flow from UN agencies (US$) of UNHCR in 1969 to that in 1972?
Make the answer very short. 0.3. What is the ratio of the Aid flow from UN agencies (US$) in UNRWA in 1969 to that in 1972?
Your answer should be compact. 0.15. What is the ratio of the Aid flow from UN agencies (US$) in UNTA in 1969 to that in 1972?
Offer a very short reply. 0.92. What is the ratio of the Aid flow from UN agencies (US$) of UNHCR in 1969 to that in 1973?
Offer a very short reply. 0.16. What is the ratio of the Aid flow from UN agencies (US$) in UNRWA in 1969 to that in 1973?
Your answer should be very brief. 0.13. What is the ratio of the Aid flow from UN agencies (US$) of UNTA in 1969 to that in 1973?
Make the answer very short. 0.6. What is the ratio of the Aid flow from UN agencies (US$) of UNAIDS in 1969 to that in 1973?
Your response must be concise. 0.37. What is the ratio of the Aid flow from UN agencies (US$) in UNHCR in 1969 to that in 1974?
Provide a succinct answer. 0.14. What is the ratio of the Aid flow from UN agencies (US$) of UNRWA in 1969 to that in 1974?
Provide a short and direct response. 0.13. What is the ratio of the Aid flow from UN agencies (US$) in UNTA in 1969 to that in 1974?
Offer a terse response. 0.8. What is the ratio of the Aid flow from UN agencies (US$) in UNAIDS in 1969 to that in 1974?
Provide a succinct answer. 0.21. What is the ratio of the Aid flow from UN agencies (US$) of UNHCR in 1970 to that in 1971?
Provide a succinct answer. 1.21. What is the ratio of the Aid flow from UN agencies (US$) in UNRWA in 1970 to that in 1971?
Keep it short and to the point. 0.16. What is the ratio of the Aid flow from UN agencies (US$) in UNTA in 1970 to that in 1971?
Keep it short and to the point. 1.41. What is the ratio of the Aid flow from UN agencies (US$) of UNAIDS in 1970 to that in 1971?
Your answer should be compact. 0.28. What is the ratio of the Aid flow from UN agencies (US$) of UNHCR in 1970 to that in 1972?
Offer a very short reply. 0.37. What is the ratio of the Aid flow from UN agencies (US$) in UNRWA in 1970 to that in 1972?
Make the answer very short. 0.16. What is the ratio of the Aid flow from UN agencies (US$) of UNTA in 1970 to that in 1972?
Ensure brevity in your answer.  1.2. What is the ratio of the Aid flow from UN agencies (US$) of UNAIDS in 1970 to that in 1972?
Offer a terse response. 0.76. What is the ratio of the Aid flow from UN agencies (US$) of UNHCR in 1970 to that in 1973?
Provide a succinct answer. 0.19. What is the ratio of the Aid flow from UN agencies (US$) in UNRWA in 1970 to that in 1973?
Your response must be concise. 0.15. What is the ratio of the Aid flow from UN agencies (US$) in UNTA in 1970 to that in 1973?
Your response must be concise. 0.78. What is the ratio of the Aid flow from UN agencies (US$) of UNAIDS in 1970 to that in 1973?
Provide a short and direct response. 0.3. What is the ratio of the Aid flow from UN agencies (US$) of UNHCR in 1970 to that in 1974?
Your answer should be very brief. 0.18. What is the ratio of the Aid flow from UN agencies (US$) in UNRWA in 1970 to that in 1974?
Provide a succinct answer. 0.14. What is the ratio of the Aid flow from UN agencies (US$) in UNTA in 1970 to that in 1974?
Give a very brief answer. 1.05. What is the ratio of the Aid flow from UN agencies (US$) in UNAIDS in 1970 to that in 1974?
Your answer should be very brief. 0.17. What is the ratio of the Aid flow from UN agencies (US$) in UNHCR in 1971 to that in 1972?
Ensure brevity in your answer.  0.3. What is the ratio of the Aid flow from UN agencies (US$) of UNRWA in 1971 to that in 1972?
Offer a terse response. 1.02. What is the ratio of the Aid flow from UN agencies (US$) of UNTA in 1971 to that in 1972?
Your answer should be very brief. 0.85. What is the ratio of the Aid flow from UN agencies (US$) in UNAIDS in 1971 to that in 1972?
Make the answer very short. 2.73. What is the ratio of the Aid flow from UN agencies (US$) in UNHCR in 1971 to that in 1973?
Provide a short and direct response. 0.16. What is the ratio of the Aid flow from UN agencies (US$) of UNRWA in 1971 to that in 1973?
Offer a very short reply. 0.93. What is the ratio of the Aid flow from UN agencies (US$) in UNTA in 1971 to that in 1973?
Provide a succinct answer. 0.56. What is the ratio of the Aid flow from UN agencies (US$) in UNAIDS in 1971 to that in 1973?
Your answer should be very brief. 1.08. What is the ratio of the Aid flow from UN agencies (US$) of UNHCR in 1971 to that in 1974?
Make the answer very short. 0.14. What is the ratio of the Aid flow from UN agencies (US$) in UNRWA in 1971 to that in 1974?
Provide a short and direct response. 0.88. What is the ratio of the Aid flow from UN agencies (US$) of UNTA in 1971 to that in 1974?
Ensure brevity in your answer.  0.74. What is the ratio of the Aid flow from UN agencies (US$) of UNAIDS in 1971 to that in 1974?
Your response must be concise. 0.62. What is the ratio of the Aid flow from UN agencies (US$) of UNHCR in 1972 to that in 1973?
Provide a short and direct response. 0.52. What is the ratio of the Aid flow from UN agencies (US$) of UNRWA in 1972 to that in 1973?
Your response must be concise. 0.91. What is the ratio of the Aid flow from UN agencies (US$) of UNTA in 1972 to that in 1973?
Provide a short and direct response. 0.65. What is the ratio of the Aid flow from UN agencies (US$) in UNAIDS in 1972 to that in 1973?
Provide a succinct answer. 0.4. What is the ratio of the Aid flow from UN agencies (US$) of UNHCR in 1972 to that in 1974?
Your response must be concise. 0.47. What is the ratio of the Aid flow from UN agencies (US$) in UNRWA in 1972 to that in 1974?
Offer a terse response. 0.86. What is the ratio of the Aid flow from UN agencies (US$) of UNTA in 1972 to that in 1974?
Offer a terse response. 0.87. What is the ratio of the Aid flow from UN agencies (US$) in UNAIDS in 1972 to that in 1974?
Ensure brevity in your answer.  0.23. What is the ratio of the Aid flow from UN agencies (US$) in UNHCR in 1973 to that in 1974?
Keep it short and to the point. 0.91. What is the ratio of the Aid flow from UN agencies (US$) in UNRWA in 1973 to that in 1974?
Keep it short and to the point. 0.94. What is the ratio of the Aid flow from UN agencies (US$) of UNTA in 1973 to that in 1974?
Offer a terse response. 1.33. What is the ratio of the Aid flow from UN agencies (US$) in UNAIDS in 1973 to that in 1974?
Provide a succinct answer. 0.57. What is the difference between the highest and the second highest Aid flow from UN agencies (US$) of UNHCR?
Keep it short and to the point. 9.00e+04. What is the difference between the highest and the second highest Aid flow from UN agencies (US$) of UNRWA?
Offer a terse response. 1.92e+07. What is the difference between the highest and the second highest Aid flow from UN agencies (US$) in UNTA?
Ensure brevity in your answer.  1.72e+06. What is the difference between the highest and the second highest Aid flow from UN agencies (US$) in UNAIDS?
Provide a succinct answer. 1.64e+06. What is the difference between the highest and the lowest Aid flow from UN agencies (US$) of UNHCR?
Offer a very short reply. 8.30e+05. What is the difference between the highest and the lowest Aid flow from UN agencies (US$) of UNRWA?
Provide a short and direct response. 3.05e+08. What is the difference between the highest and the lowest Aid flow from UN agencies (US$) in UNTA?
Your response must be concise. 3.52e+06. What is the difference between the highest and the lowest Aid flow from UN agencies (US$) in UNAIDS?
Offer a terse response. 3.58e+06. 